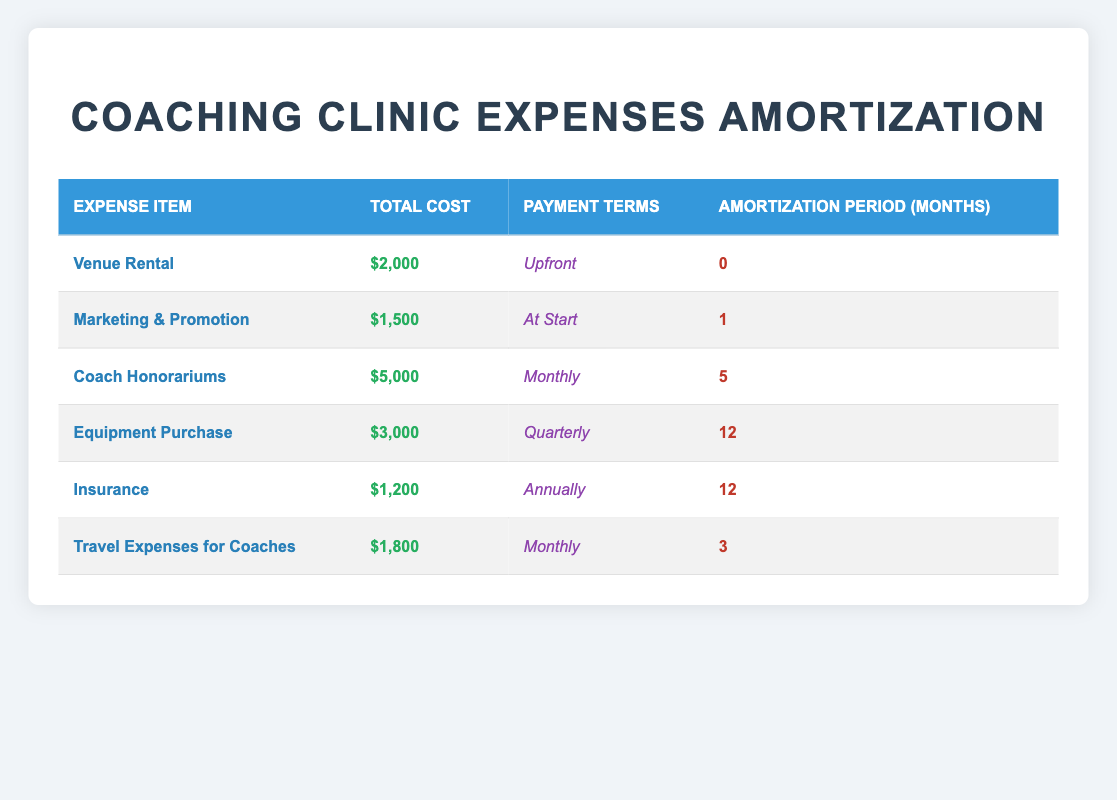What is the total cost for the venue rental? The total cost for the venue rental is directly listed in the table under the "Total Cost" column for the "Venue Rental" expense item. It states that the total cost is $2,000.
Answer: $2,000 How long is the amortization period for the equipment purchase? The amortization period for the equipment purchase can be found in the "Amortization Period (Months)" column corresponding to the "Equipment Purchase" expense item. It shows 12 months.
Answer: 12 months What is the total amount for coach honorariums and travel expenses for coaches combined? To find the total amount for coach honorariums and travel expenses for coaches, we look at the total costs for these two expenses: Coach Honorariums is $5,000 and Travel Expenses for Coaches is $1,800. Adding these gives $5,000 + $1,800 = $6,800.
Answer: $6,800 Is the payment term for marketing & promotion categorized as "Monthly"? The payment term for marketing & promotion is stated in the "Payment Terms" column for that expense item. It is noted as "At Start," not "Monthly," which allows us to confirm the statement is false.
Answer: No What percentage of the total clinic expenses is accounted for by insurance? First, we calculate the total costs of all expenses listed. The total costs are $2,000 (Venue Rental) + $1,500 (Marketing & Promotion) + $5,000 (Coach Honorariums) + $3,000 (Equipment Purchase) + $1,200 (Insurance) + $1,800 (Travel Expenses). This sums up to $14,500. The insurance cost is $1,200. To find the percentage, we use the formula (Insurance Cost / Total Costs) * 100 = ($1,200 / $14,500) * 100 ≈ 8.28%.
Answer: 8.28% 